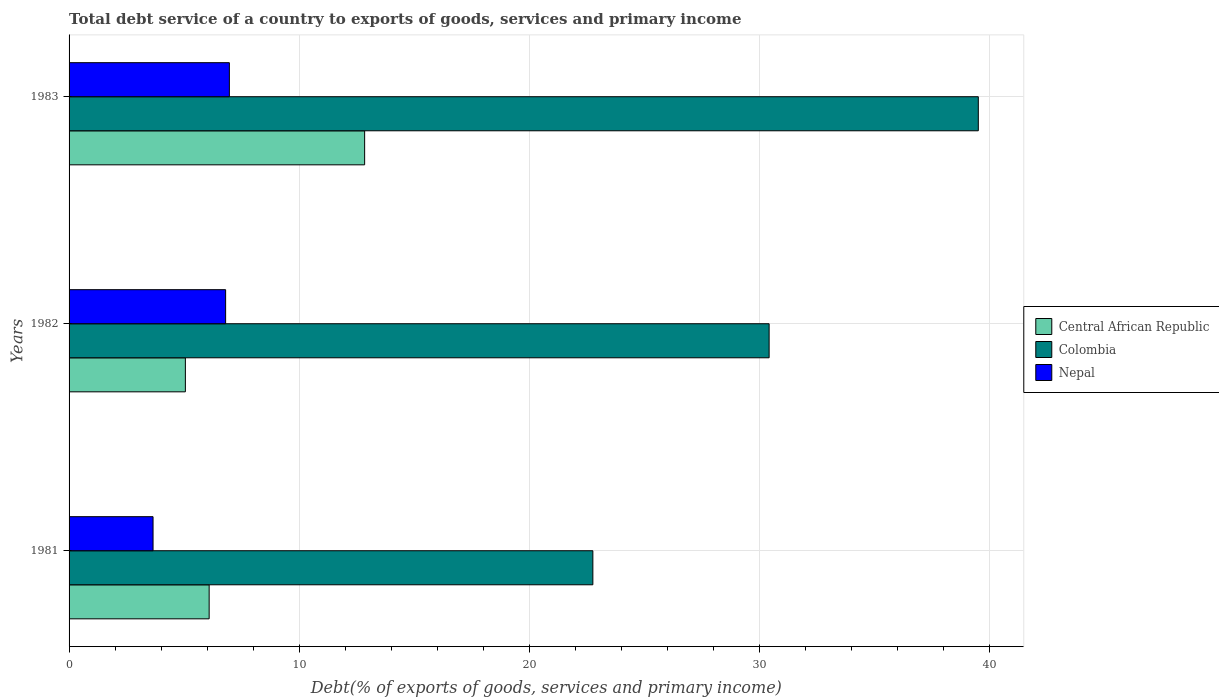How many different coloured bars are there?
Provide a short and direct response. 3. How many groups of bars are there?
Provide a succinct answer. 3. Are the number of bars per tick equal to the number of legend labels?
Ensure brevity in your answer.  Yes. How many bars are there on the 2nd tick from the top?
Make the answer very short. 3. How many bars are there on the 1st tick from the bottom?
Your answer should be very brief. 3. What is the total debt service in Colombia in 1982?
Your answer should be very brief. 30.42. Across all years, what is the maximum total debt service in Nepal?
Ensure brevity in your answer.  6.97. Across all years, what is the minimum total debt service in Central African Republic?
Give a very brief answer. 5.05. In which year was the total debt service in Nepal maximum?
Offer a terse response. 1983. In which year was the total debt service in Central African Republic minimum?
Give a very brief answer. 1982. What is the total total debt service in Central African Republic in the graph?
Offer a very short reply. 23.99. What is the difference between the total debt service in Central African Republic in 1982 and that in 1983?
Provide a short and direct response. -7.79. What is the difference between the total debt service in Central African Republic in 1983 and the total debt service in Colombia in 1982?
Keep it short and to the point. -17.58. What is the average total debt service in Central African Republic per year?
Offer a terse response. 8. In the year 1982, what is the difference between the total debt service in Central African Republic and total debt service in Nepal?
Ensure brevity in your answer.  -1.75. In how many years, is the total debt service in Colombia greater than 4 %?
Your response must be concise. 3. What is the ratio of the total debt service in Nepal in 1982 to that in 1983?
Provide a short and direct response. 0.98. Is the difference between the total debt service in Central African Republic in 1981 and 1982 greater than the difference between the total debt service in Nepal in 1981 and 1982?
Offer a terse response. Yes. What is the difference between the highest and the second highest total debt service in Nepal?
Make the answer very short. 0.16. What is the difference between the highest and the lowest total debt service in Nepal?
Make the answer very short. 3.32. What does the 3rd bar from the bottom in 1981 represents?
Offer a terse response. Nepal. How many years are there in the graph?
Your answer should be very brief. 3. What is the difference between two consecutive major ticks on the X-axis?
Keep it short and to the point. 10. Are the values on the major ticks of X-axis written in scientific E-notation?
Keep it short and to the point. No. What is the title of the graph?
Give a very brief answer. Total debt service of a country to exports of goods, services and primary income. What is the label or title of the X-axis?
Offer a terse response. Debt(% of exports of goods, services and primary income). What is the label or title of the Y-axis?
Keep it short and to the point. Years. What is the Debt(% of exports of goods, services and primary income) in Central African Republic in 1981?
Give a very brief answer. 6.09. What is the Debt(% of exports of goods, services and primary income) in Colombia in 1981?
Keep it short and to the point. 22.76. What is the Debt(% of exports of goods, services and primary income) of Nepal in 1981?
Your answer should be very brief. 3.65. What is the Debt(% of exports of goods, services and primary income) in Central African Republic in 1982?
Ensure brevity in your answer.  5.05. What is the Debt(% of exports of goods, services and primary income) in Colombia in 1982?
Make the answer very short. 30.42. What is the Debt(% of exports of goods, services and primary income) of Nepal in 1982?
Provide a succinct answer. 6.8. What is the Debt(% of exports of goods, services and primary income) in Central African Republic in 1983?
Give a very brief answer. 12.84. What is the Debt(% of exports of goods, services and primary income) in Colombia in 1983?
Offer a terse response. 39.51. What is the Debt(% of exports of goods, services and primary income) of Nepal in 1983?
Offer a very short reply. 6.97. Across all years, what is the maximum Debt(% of exports of goods, services and primary income) in Central African Republic?
Make the answer very short. 12.84. Across all years, what is the maximum Debt(% of exports of goods, services and primary income) of Colombia?
Give a very brief answer. 39.51. Across all years, what is the maximum Debt(% of exports of goods, services and primary income) in Nepal?
Offer a very short reply. 6.97. Across all years, what is the minimum Debt(% of exports of goods, services and primary income) in Central African Republic?
Offer a very short reply. 5.05. Across all years, what is the minimum Debt(% of exports of goods, services and primary income) in Colombia?
Offer a terse response. 22.76. Across all years, what is the minimum Debt(% of exports of goods, services and primary income) of Nepal?
Ensure brevity in your answer.  3.65. What is the total Debt(% of exports of goods, services and primary income) in Central African Republic in the graph?
Offer a very short reply. 23.99. What is the total Debt(% of exports of goods, services and primary income) in Colombia in the graph?
Ensure brevity in your answer.  92.7. What is the total Debt(% of exports of goods, services and primary income) of Nepal in the graph?
Your answer should be compact. 17.42. What is the difference between the Debt(% of exports of goods, services and primary income) of Central African Republic in 1981 and that in 1982?
Give a very brief answer. 1.03. What is the difference between the Debt(% of exports of goods, services and primary income) of Colombia in 1981 and that in 1982?
Your answer should be compact. -7.66. What is the difference between the Debt(% of exports of goods, services and primary income) of Nepal in 1981 and that in 1982?
Give a very brief answer. -3.15. What is the difference between the Debt(% of exports of goods, services and primary income) in Central African Republic in 1981 and that in 1983?
Give a very brief answer. -6.76. What is the difference between the Debt(% of exports of goods, services and primary income) of Colombia in 1981 and that in 1983?
Provide a short and direct response. -16.75. What is the difference between the Debt(% of exports of goods, services and primary income) in Nepal in 1981 and that in 1983?
Keep it short and to the point. -3.32. What is the difference between the Debt(% of exports of goods, services and primary income) in Central African Republic in 1982 and that in 1983?
Provide a succinct answer. -7.79. What is the difference between the Debt(% of exports of goods, services and primary income) of Colombia in 1982 and that in 1983?
Your response must be concise. -9.09. What is the difference between the Debt(% of exports of goods, services and primary income) in Nepal in 1982 and that in 1983?
Give a very brief answer. -0.16. What is the difference between the Debt(% of exports of goods, services and primary income) in Central African Republic in 1981 and the Debt(% of exports of goods, services and primary income) in Colombia in 1982?
Your answer should be very brief. -24.33. What is the difference between the Debt(% of exports of goods, services and primary income) of Central African Republic in 1981 and the Debt(% of exports of goods, services and primary income) of Nepal in 1982?
Your response must be concise. -0.72. What is the difference between the Debt(% of exports of goods, services and primary income) of Colombia in 1981 and the Debt(% of exports of goods, services and primary income) of Nepal in 1982?
Offer a very short reply. 15.96. What is the difference between the Debt(% of exports of goods, services and primary income) of Central African Republic in 1981 and the Debt(% of exports of goods, services and primary income) of Colombia in 1983?
Ensure brevity in your answer.  -33.42. What is the difference between the Debt(% of exports of goods, services and primary income) in Central African Republic in 1981 and the Debt(% of exports of goods, services and primary income) in Nepal in 1983?
Your answer should be very brief. -0.88. What is the difference between the Debt(% of exports of goods, services and primary income) of Colombia in 1981 and the Debt(% of exports of goods, services and primary income) of Nepal in 1983?
Provide a succinct answer. 15.8. What is the difference between the Debt(% of exports of goods, services and primary income) of Central African Republic in 1982 and the Debt(% of exports of goods, services and primary income) of Colombia in 1983?
Your response must be concise. -34.46. What is the difference between the Debt(% of exports of goods, services and primary income) in Central African Republic in 1982 and the Debt(% of exports of goods, services and primary income) in Nepal in 1983?
Make the answer very short. -1.91. What is the difference between the Debt(% of exports of goods, services and primary income) of Colombia in 1982 and the Debt(% of exports of goods, services and primary income) of Nepal in 1983?
Give a very brief answer. 23.46. What is the average Debt(% of exports of goods, services and primary income) in Central African Republic per year?
Ensure brevity in your answer.  8. What is the average Debt(% of exports of goods, services and primary income) in Colombia per year?
Your response must be concise. 30.9. What is the average Debt(% of exports of goods, services and primary income) in Nepal per year?
Your answer should be very brief. 5.81. In the year 1981, what is the difference between the Debt(% of exports of goods, services and primary income) in Central African Republic and Debt(% of exports of goods, services and primary income) in Colombia?
Provide a short and direct response. -16.67. In the year 1981, what is the difference between the Debt(% of exports of goods, services and primary income) of Central African Republic and Debt(% of exports of goods, services and primary income) of Nepal?
Offer a very short reply. 2.44. In the year 1981, what is the difference between the Debt(% of exports of goods, services and primary income) of Colombia and Debt(% of exports of goods, services and primary income) of Nepal?
Provide a succinct answer. 19.11. In the year 1982, what is the difference between the Debt(% of exports of goods, services and primary income) in Central African Republic and Debt(% of exports of goods, services and primary income) in Colombia?
Offer a very short reply. -25.37. In the year 1982, what is the difference between the Debt(% of exports of goods, services and primary income) in Central African Republic and Debt(% of exports of goods, services and primary income) in Nepal?
Offer a terse response. -1.75. In the year 1982, what is the difference between the Debt(% of exports of goods, services and primary income) of Colombia and Debt(% of exports of goods, services and primary income) of Nepal?
Your answer should be compact. 23.62. In the year 1983, what is the difference between the Debt(% of exports of goods, services and primary income) in Central African Republic and Debt(% of exports of goods, services and primary income) in Colombia?
Provide a succinct answer. -26.67. In the year 1983, what is the difference between the Debt(% of exports of goods, services and primary income) of Central African Republic and Debt(% of exports of goods, services and primary income) of Nepal?
Offer a terse response. 5.88. In the year 1983, what is the difference between the Debt(% of exports of goods, services and primary income) in Colombia and Debt(% of exports of goods, services and primary income) in Nepal?
Give a very brief answer. 32.55. What is the ratio of the Debt(% of exports of goods, services and primary income) of Central African Republic in 1981 to that in 1982?
Make the answer very short. 1.2. What is the ratio of the Debt(% of exports of goods, services and primary income) in Colombia in 1981 to that in 1982?
Provide a short and direct response. 0.75. What is the ratio of the Debt(% of exports of goods, services and primary income) in Nepal in 1981 to that in 1982?
Offer a very short reply. 0.54. What is the ratio of the Debt(% of exports of goods, services and primary income) of Central African Republic in 1981 to that in 1983?
Make the answer very short. 0.47. What is the ratio of the Debt(% of exports of goods, services and primary income) of Colombia in 1981 to that in 1983?
Your response must be concise. 0.58. What is the ratio of the Debt(% of exports of goods, services and primary income) of Nepal in 1981 to that in 1983?
Offer a terse response. 0.52. What is the ratio of the Debt(% of exports of goods, services and primary income) in Central African Republic in 1982 to that in 1983?
Offer a very short reply. 0.39. What is the ratio of the Debt(% of exports of goods, services and primary income) in Colombia in 1982 to that in 1983?
Your response must be concise. 0.77. What is the ratio of the Debt(% of exports of goods, services and primary income) of Nepal in 1982 to that in 1983?
Provide a short and direct response. 0.98. What is the difference between the highest and the second highest Debt(% of exports of goods, services and primary income) of Central African Republic?
Your answer should be very brief. 6.76. What is the difference between the highest and the second highest Debt(% of exports of goods, services and primary income) of Colombia?
Your answer should be compact. 9.09. What is the difference between the highest and the second highest Debt(% of exports of goods, services and primary income) of Nepal?
Ensure brevity in your answer.  0.16. What is the difference between the highest and the lowest Debt(% of exports of goods, services and primary income) of Central African Republic?
Keep it short and to the point. 7.79. What is the difference between the highest and the lowest Debt(% of exports of goods, services and primary income) in Colombia?
Your response must be concise. 16.75. What is the difference between the highest and the lowest Debt(% of exports of goods, services and primary income) in Nepal?
Keep it short and to the point. 3.32. 